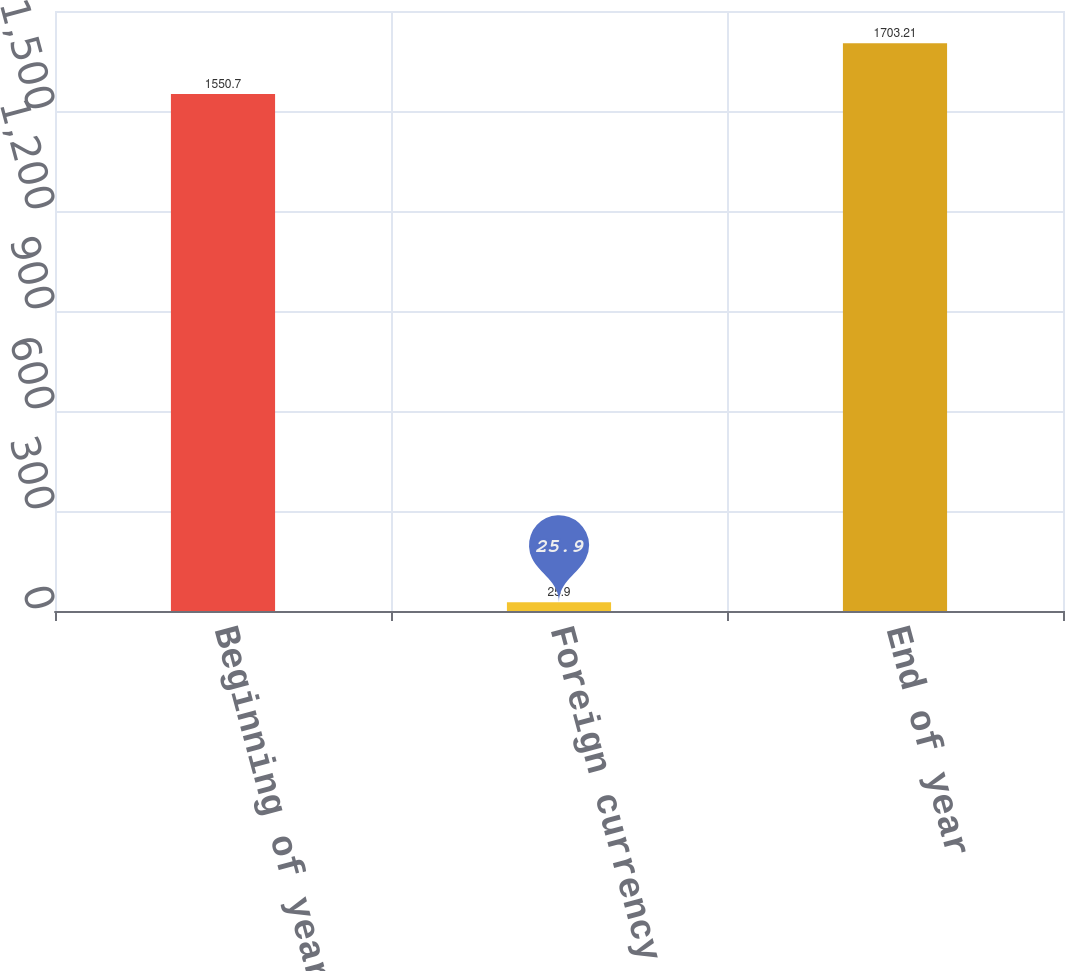<chart> <loc_0><loc_0><loc_500><loc_500><bar_chart><fcel>Beginning of year<fcel>Foreign currency fluctuations<fcel>End of year<nl><fcel>1550.7<fcel>25.9<fcel>1703.21<nl></chart> 